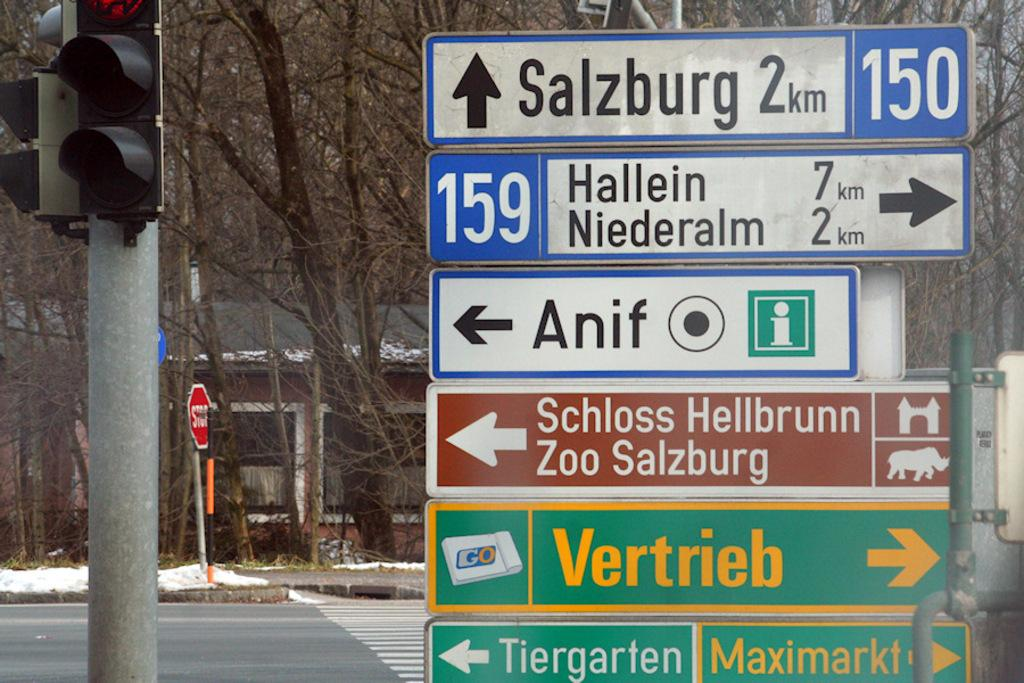<image>
Offer a succinct explanation of the picture presented. A points to Salzburg with 2 km ahead. 